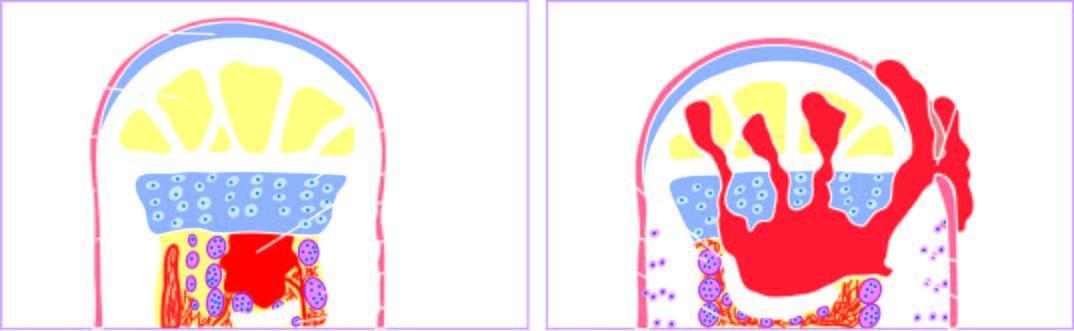what does the extension of infection into the joint space, epiphysis and the skin produce?
Answer the question using a single word or phrase. A draining sinus 